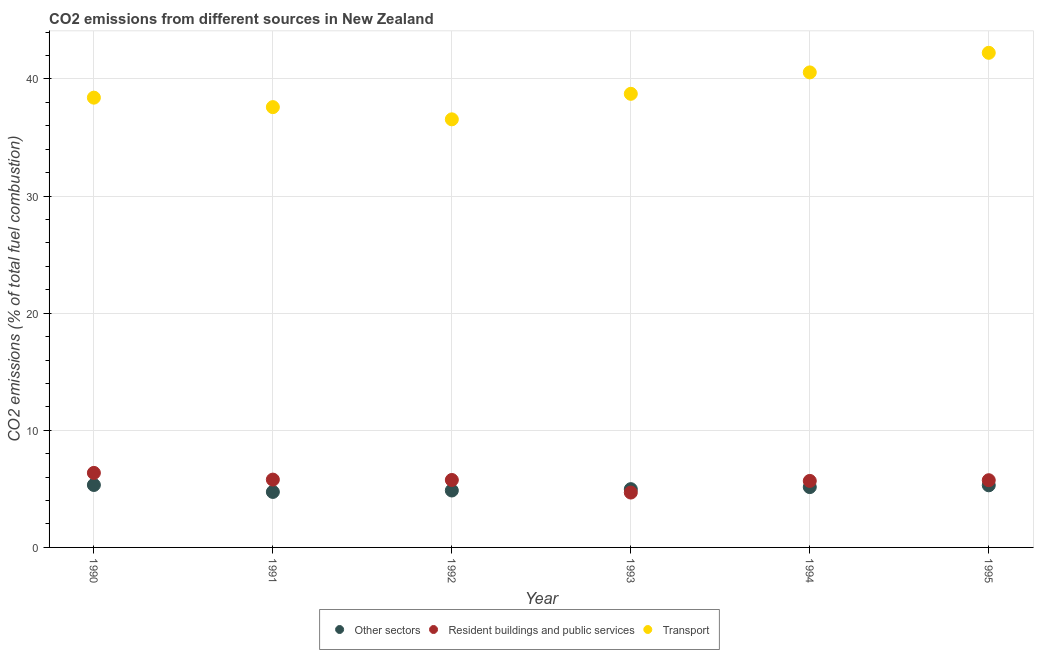How many different coloured dotlines are there?
Make the answer very short. 3. Is the number of dotlines equal to the number of legend labels?
Your response must be concise. Yes. What is the percentage of co2 emissions from transport in 1991?
Your answer should be compact. 37.59. Across all years, what is the maximum percentage of co2 emissions from resident buildings and public services?
Your response must be concise. 6.36. Across all years, what is the minimum percentage of co2 emissions from other sectors?
Offer a very short reply. 4.74. In which year was the percentage of co2 emissions from resident buildings and public services minimum?
Offer a terse response. 1993. What is the total percentage of co2 emissions from transport in the graph?
Provide a short and direct response. 234.03. What is the difference between the percentage of co2 emissions from transport in 1990 and that in 1991?
Provide a succinct answer. 0.81. What is the difference between the percentage of co2 emissions from resident buildings and public services in 1993 and the percentage of co2 emissions from other sectors in 1991?
Make the answer very short. -0.05. What is the average percentage of co2 emissions from resident buildings and public services per year?
Provide a short and direct response. 5.67. In the year 1991, what is the difference between the percentage of co2 emissions from other sectors and percentage of co2 emissions from transport?
Give a very brief answer. -32.85. In how many years, is the percentage of co2 emissions from resident buildings and public services greater than 14 %?
Keep it short and to the point. 0. What is the ratio of the percentage of co2 emissions from other sectors in 1991 to that in 1995?
Your answer should be very brief. 0.89. Is the difference between the percentage of co2 emissions from transport in 1991 and 1992 greater than the difference between the percentage of co2 emissions from resident buildings and public services in 1991 and 1992?
Provide a short and direct response. Yes. What is the difference between the highest and the second highest percentage of co2 emissions from transport?
Offer a very short reply. 1.67. What is the difference between the highest and the lowest percentage of co2 emissions from resident buildings and public services?
Your response must be concise. 1.68. In how many years, is the percentage of co2 emissions from resident buildings and public services greater than the average percentage of co2 emissions from resident buildings and public services taken over all years?
Make the answer very short. 5. Is it the case that in every year, the sum of the percentage of co2 emissions from other sectors and percentage of co2 emissions from resident buildings and public services is greater than the percentage of co2 emissions from transport?
Provide a succinct answer. No. Does the percentage of co2 emissions from transport monotonically increase over the years?
Your answer should be very brief. No. Is the percentage of co2 emissions from transport strictly greater than the percentage of co2 emissions from other sectors over the years?
Your answer should be compact. Yes. How many dotlines are there?
Provide a short and direct response. 3. How many years are there in the graph?
Your response must be concise. 6. Are the values on the major ticks of Y-axis written in scientific E-notation?
Your answer should be very brief. No. Does the graph contain grids?
Give a very brief answer. Yes. How are the legend labels stacked?
Your response must be concise. Horizontal. What is the title of the graph?
Keep it short and to the point. CO2 emissions from different sources in New Zealand. What is the label or title of the X-axis?
Your answer should be very brief. Year. What is the label or title of the Y-axis?
Make the answer very short. CO2 emissions (% of total fuel combustion). What is the CO2 emissions (% of total fuel combustion) in Other sectors in 1990?
Offer a terse response. 5.33. What is the CO2 emissions (% of total fuel combustion) in Resident buildings and public services in 1990?
Your answer should be very brief. 6.36. What is the CO2 emissions (% of total fuel combustion) of Transport in 1990?
Offer a very short reply. 38.4. What is the CO2 emissions (% of total fuel combustion) in Other sectors in 1991?
Provide a succinct answer. 4.74. What is the CO2 emissions (% of total fuel combustion) of Resident buildings and public services in 1991?
Make the answer very short. 5.79. What is the CO2 emissions (% of total fuel combustion) of Transport in 1991?
Give a very brief answer. 37.59. What is the CO2 emissions (% of total fuel combustion) in Other sectors in 1992?
Your answer should be very brief. 4.86. What is the CO2 emissions (% of total fuel combustion) in Resident buildings and public services in 1992?
Ensure brevity in your answer.  5.76. What is the CO2 emissions (% of total fuel combustion) in Transport in 1992?
Provide a succinct answer. 36.55. What is the CO2 emissions (% of total fuel combustion) in Other sectors in 1993?
Offer a terse response. 4.98. What is the CO2 emissions (% of total fuel combustion) in Resident buildings and public services in 1993?
Ensure brevity in your answer.  4.68. What is the CO2 emissions (% of total fuel combustion) in Transport in 1993?
Your answer should be very brief. 38.72. What is the CO2 emissions (% of total fuel combustion) in Other sectors in 1994?
Ensure brevity in your answer.  5.15. What is the CO2 emissions (% of total fuel combustion) of Resident buildings and public services in 1994?
Offer a very short reply. 5.68. What is the CO2 emissions (% of total fuel combustion) in Transport in 1994?
Your answer should be compact. 40.55. What is the CO2 emissions (% of total fuel combustion) in Other sectors in 1995?
Ensure brevity in your answer.  5.3. What is the CO2 emissions (% of total fuel combustion) of Resident buildings and public services in 1995?
Make the answer very short. 5.74. What is the CO2 emissions (% of total fuel combustion) of Transport in 1995?
Make the answer very short. 42.22. Across all years, what is the maximum CO2 emissions (% of total fuel combustion) in Other sectors?
Keep it short and to the point. 5.33. Across all years, what is the maximum CO2 emissions (% of total fuel combustion) in Resident buildings and public services?
Provide a succinct answer. 6.36. Across all years, what is the maximum CO2 emissions (% of total fuel combustion) of Transport?
Make the answer very short. 42.22. Across all years, what is the minimum CO2 emissions (% of total fuel combustion) of Other sectors?
Keep it short and to the point. 4.74. Across all years, what is the minimum CO2 emissions (% of total fuel combustion) in Resident buildings and public services?
Provide a short and direct response. 4.68. Across all years, what is the minimum CO2 emissions (% of total fuel combustion) of Transport?
Offer a very short reply. 36.55. What is the total CO2 emissions (% of total fuel combustion) in Other sectors in the graph?
Your answer should be very brief. 30.36. What is the total CO2 emissions (% of total fuel combustion) in Resident buildings and public services in the graph?
Give a very brief answer. 34.01. What is the total CO2 emissions (% of total fuel combustion) of Transport in the graph?
Ensure brevity in your answer.  234.03. What is the difference between the CO2 emissions (% of total fuel combustion) in Other sectors in 1990 and that in 1991?
Give a very brief answer. 0.59. What is the difference between the CO2 emissions (% of total fuel combustion) in Resident buildings and public services in 1990 and that in 1991?
Offer a very short reply. 0.57. What is the difference between the CO2 emissions (% of total fuel combustion) in Transport in 1990 and that in 1991?
Give a very brief answer. 0.81. What is the difference between the CO2 emissions (% of total fuel combustion) of Other sectors in 1990 and that in 1992?
Give a very brief answer. 0.47. What is the difference between the CO2 emissions (% of total fuel combustion) in Resident buildings and public services in 1990 and that in 1992?
Make the answer very short. 0.6. What is the difference between the CO2 emissions (% of total fuel combustion) of Transport in 1990 and that in 1992?
Provide a succinct answer. 1.85. What is the difference between the CO2 emissions (% of total fuel combustion) of Other sectors in 1990 and that in 1993?
Give a very brief answer. 0.36. What is the difference between the CO2 emissions (% of total fuel combustion) of Resident buildings and public services in 1990 and that in 1993?
Give a very brief answer. 1.68. What is the difference between the CO2 emissions (% of total fuel combustion) of Transport in 1990 and that in 1993?
Ensure brevity in your answer.  -0.33. What is the difference between the CO2 emissions (% of total fuel combustion) of Other sectors in 1990 and that in 1994?
Ensure brevity in your answer.  0.18. What is the difference between the CO2 emissions (% of total fuel combustion) of Resident buildings and public services in 1990 and that in 1994?
Ensure brevity in your answer.  0.68. What is the difference between the CO2 emissions (% of total fuel combustion) in Transport in 1990 and that in 1994?
Your answer should be very brief. -2.16. What is the difference between the CO2 emissions (% of total fuel combustion) in Other sectors in 1990 and that in 1995?
Keep it short and to the point. 0.03. What is the difference between the CO2 emissions (% of total fuel combustion) in Resident buildings and public services in 1990 and that in 1995?
Offer a terse response. 0.62. What is the difference between the CO2 emissions (% of total fuel combustion) of Transport in 1990 and that in 1995?
Give a very brief answer. -3.83. What is the difference between the CO2 emissions (% of total fuel combustion) in Other sectors in 1991 and that in 1992?
Provide a succinct answer. -0.12. What is the difference between the CO2 emissions (% of total fuel combustion) in Resident buildings and public services in 1991 and that in 1992?
Provide a short and direct response. 0.03. What is the difference between the CO2 emissions (% of total fuel combustion) of Transport in 1991 and that in 1992?
Offer a very short reply. 1.04. What is the difference between the CO2 emissions (% of total fuel combustion) in Other sectors in 1991 and that in 1993?
Ensure brevity in your answer.  -0.24. What is the difference between the CO2 emissions (% of total fuel combustion) of Resident buildings and public services in 1991 and that in 1993?
Provide a succinct answer. 1.1. What is the difference between the CO2 emissions (% of total fuel combustion) of Transport in 1991 and that in 1993?
Provide a succinct answer. -1.14. What is the difference between the CO2 emissions (% of total fuel combustion) in Other sectors in 1991 and that in 1994?
Your answer should be compact. -0.41. What is the difference between the CO2 emissions (% of total fuel combustion) of Resident buildings and public services in 1991 and that in 1994?
Give a very brief answer. 0.11. What is the difference between the CO2 emissions (% of total fuel combustion) of Transport in 1991 and that in 1994?
Keep it short and to the point. -2.96. What is the difference between the CO2 emissions (% of total fuel combustion) in Other sectors in 1991 and that in 1995?
Make the answer very short. -0.57. What is the difference between the CO2 emissions (% of total fuel combustion) of Resident buildings and public services in 1991 and that in 1995?
Provide a short and direct response. 0.05. What is the difference between the CO2 emissions (% of total fuel combustion) in Transport in 1991 and that in 1995?
Offer a terse response. -4.64. What is the difference between the CO2 emissions (% of total fuel combustion) of Other sectors in 1992 and that in 1993?
Provide a short and direct response. -0.12. What is the difference between the CO2 emissions (% of total fuel combustion) of Resident buildings and public services in 1992 and that in 1993?
Your answer should be compact. 1.07. What is the difference between the CO2 emissions (% of total fuel combustion) in Transport in 1992 and that in 1993?
Offer a terse response. -2.18. What is the difference between the CO2 emissions (% of total fuel combustion) of Other sectors in 1992 and that in 1994?
Offer a terse response. -0.29. What is the difference between the CO2 emissions (% of total fuel combustion) in Resident buildings and public services in 1992 and that in 1994?
Keep it short and to the point. 0.08. What is the difference between the CO2 emissions (% of total fuel combustion) in Transport in 1992 and that in 1994?
Your response must be concise. -4.01. What is the difference between the CO2 emissions (% of total fuel combustion) of Other sectors in 1992 and that in 1995?
Your response must be concise. -0.44. What is the difference between the CO2 emissions (% of total fuel combustion) of Resident buildings and public services in 1992 and that in 1995?
Make the answer very short. 0.02. What is the difference between the CO2 emissions (% of total fuel combustion) of Transport in 1992 and that in 1995?
Provide a short and direct response. -5.68. What is the difference between the CO2 emissions (% of total fuel combustion) in Other sectors in 1993 and that in 1994?
Make the answer very short. -0.17. What is the difference between the CO2 emissions (% of total fuel combustion) in Resident buildings and public services in 1993 and that in 1994?
Provide a short and direct response. -0.99. What is the difference between the CO2 emissions (% of total fuel combustion) in Transport in 1993 and that in 1994?
Provide a succinct answer. -1.83. What is the difference between the CO2 emissions (% of total fuel combustion) of Other sectors in 1993 and that in 1995?
Keep it short and to the point. -0.33. What is the difference between the CO2 emissions (% of total fuel combustion) in Resident buildings and public services in 1993 and that in 1995?
Your response must be concise. -1.05. What is the difference between the CO2 emissions (% of total fuel combustion) in Transport in 1993 and that in 1995?
Provide a succinct answer. -3.5. What is the difference between the CO2 emissions (% of total fuel combustion) in Other sectors in 1994 and that in 1995?
Your answer should be very brief. -0.15. What is the difference between the CO2 emissions (% of total fuel combustion) in Resident buildings and public services in 1994 and that in 1995?
Your answer should be very brief. -0.06. What is the difference between the CO2 emissions (% of total fuel combustion) in Transport in 1994 and that in 1995?
Keep it short and to the point. -1.67. What is the difference between the CO2 emissions (% of total fuel combustion) of Other sectors in 1990 and the CO2 emissions (% of total fuel combustion) of Resident buildings and public services in 1991?
Provide a succinct answer. -0.46. What is the difference between the CO2 emissions (% of total fuel combustion) in Other sectors in 1990 and the CO2 emissions (% of total fuel combustion) in Transport in 1991?
Offer a terse response. -32.26. What is the difference between the CO2 emissions (% of total fuel combustion) of Resident buildings and public services in 1990 and the CO2 emissions (% of total fuel combustion) of Transport in 1991?
Offer a very short reply. -31.23. What is the difference between the CO2 emissions (% of total fuel combustion) of Other sectors in 1990 and the CO2 emissions (% of total fuel combustion) of Resident buildings and public services in 1992?
Give a very brief answer. -0.43. What is the difference between the CO2 emissions (% of total fuel combustion) in Other sectors in 1990 and the CO2 emissions (% of total fuel combustion) in Transport in 1992?
Ensure brevity in your answer.  -31.21. What is the difference between the CO2 emissions (% of total fuel combustion) in Resident buildings and public services in 1990 and the CO2 emissions (% of total fuel combustion) in Transport in 1992?
Give a very brief answer. -30.18. What is the difference between the CO2 emissions (% of total fuel combustion) in Other sectors in 1990 and the CO2 emissions (% of total fuel combustion) in Resident buildings and public services in 1993?
Offer a terse response. 0.65. What is the difference between the CO2 emissions (% of total fuel combustion) in Other sectors in 1990 and the CO2 emissions (% of total fuel combustion) in Transport in 1993?
Offer a very short reply. -33.39. What is the difference between the CO2 emissions (% of total fuel combustion) of Resident buildings and public services in 1990 and the CO2 emissions (% of total fuel combustion) of Transport in 1993?
Keep it short and to the point. -32.36. What is the difference between the CO2 emissions (% of total fuel combustion) of Other sectors in 1990 and the CO2 emissions (% of total fuel combustion) of Resident buildings and public services in 1994?
Your answer should be compact. -0.35. What is the difference between the CO2 emissions (% of total fuel combustion) of Other sectors in 1990 and the CO2 emissions (% of total fuel combustion) of Transport in 1994?
Give a very brief answer. -35.22. What is the difference between the CO2 emissions (% of total fuel combustion) in Resident buildings and public services in 1990 and the CO2 emissions (% of total fuel combustion) in Transport in 1994?
Offer a very short reply. -34.19. What is the difference between the CO2 emissions (% of total fuel combustion) in Other sectors in 1990 and the CO2 emissions (% of total fuel combustion) in Resident buildings and public services in 1995?
Your answer should be compact. -0.41. What is the difference between the CO2 emissions (% of total fuel combustion) of Other sectors in 1990 and the CO2 emissions (% of total fuel combustion) of Transport in 1995?
Your answer should be very brief. -36.89. What is the difference between the CO2 emissions (% of total fuel combustion) in Resident buildings and public services in 1990 and the CO2 emissions (% of total fuel combustion) in Transport in 1995?
Offer a very short reply. -35.86. What is the difference between the CO2 emissions (% of total fuel combustion) in Other sectors in 1991 and the CO2 emissions (% of total fuel combustion) in Resident buildings and public services in 1992?
Keep it short and to the point. -1.02. What is the difference between the CO2 emissions (% of total fuel combustion) in Other sectors in 1991 and the CO2 emissions (% of total fuel combustion) in Transport in 1992?
Offer a very short reply. -31.81. What is the difference between the CO2 emissions (% of total fuel combustion) of Resident buildings and public services in 1991 and the CO2 emissions (% of total fuel combustion) of Transport in 1992?
Offer a very short reply. -30.76. What is the difference between the CO2 emissions (% of total fuel combustion) of Other sectors in 1991 and the CO2 emissions (% of total fuel combustion) of Resident buildings and public services in 1993?
Your response must be concise. 0.05. What is the difference between the CO2 emissions (% of total fuel combustion) in Other sectors in 1991 and the CO2 emissions (% of total fuel combustion) in Transport in 1993?
Provide a succinct answer. -33.99. What is the difference between the CO2 emissions (% of total fuel combustion) of Resident buildings and public services in 1991 and the CO2 emissions (% of total fuel combustion) of Transport in 1993?
Your answer should be very brief. -32.93. What is the difference between the CO2 emissions (% of total fuel combustion) of Other sectors in 1991 and the CO2 emissions (% of total fuel combustion) of Resident buildings and public services in 1994?
Your answer should be very brief. -0.94. What is the difference between the CO2 emissions (% of total fuel combustion) in Other sectors in 1991 and the CO2 emissions (% of total fuel combustion) in Transport in 1994?
Your answer should be compact. -35.81. What is the difference between the CO2 emissions (% of total fuel combustion) of Resident buildings and public services in 1991 and the CO2 emissions (% of total fuel combustion) of Transport in 1994?
Offer a very short reply. -34.76. What is the difference between the CO2 emissions (% of total fuel combustion) of Other sectors in 1991 and the CO2 emissions (% of total fuel combustion) of Resident buildings and public services in 1995?
Provide a short and direct response. -1. What is the difference between the CO2 emissions (% of total fuel combustion) of Other sectors in 1991 and the CO2 emissions (% of total fuel combustion) of Transport in 1995?
Ensure brevity in your answer.  -37.49. What is the difference between the CO2 emissions (% of total fuel combustion) of Resident buildings and public services in 1991 and the CO2 emissions (% of total fuel combustion) of Transport in 1995?
Ensure brevity in your answer.  -36.43. What is the difference between the CO2 emissions (% of total fuel combustion) of Other sectors in 1992 and the CO2 emissions (% of total fuel combustion) of Resident buildings and public services in 1993?
Offer a very short reply. 0.17. What is the difference between the CO2 emissions (% of total fuel combustion) of Other sectors in 1992 and the CO2 emissions (% of total fuel combustion) of Transport in 1993?
Your answer should be very brief. -33.86. What is the difference between the CO2 emissions (% of total fuel combustion) of Resident buildings and public services in 1992 and the CO2 emissions (% of total fuel combustion) of Transport in 1993?
Ensure brevity in your answer.  -32.97. What is the difference between the CO2 emissions (% of total fuel combustion) of Other sectors in 1992 and the CO2 emissions (% of total fuel combustion) of Resident buildings and public services in 1994?
Make the answer very short. -0.82. What is the difference between the CO2 emissions (% of total fuel combustion) in Other sectors in 1992 and the CO2 emissions (% of total fuel combustion) in Transport in 1994?
Make the answer very short. -35.69. What is the difference between the CO2 emissions (% of total fuel combustion) of Resident buildings and public services in 1992 and the CO2 emissions (% of total fuel combustion) of Transport in 1994?
Provide a short and direct response. -34.79. What is the difference between the CO2 emissions (% of total fuel combustion) in Other sectors in 1992 and the CO2 emissions (% of total fuel combustion) in Resident buildings and public services in 1995?
Offer a terse response. -0.88. What is the difference between the CO2 emissions (% of total fuel combustion) of Other sectors in 1992 and the CO2 emissions (% of total fuel combustion) of Transport in 1995?
Keep it short and to the point. -37.36. What is the difference between the CO2 emissions (% of total fuel combustion) in Resident buildings and public services in 1992 and the CO2 emissions (% of total fuel combustion) in Transport in 1995?
Ensure brevity in your answer.  -36.47. What is the difference between the CO2 emissions (% of total fuel combustion) in Other sectors in 1993 and the CO2 emissions (% of total fuel combustion) in Resident buildings and public services in 1994?
Your response must be concise. -0.7. What is the difference between the CO2 emissions (% of total fuel combustion) in Other sectors in 1993 and the CO2 emissions (% of total fuel combustion) in Transport in 1994?
Provide a succinct answer. -35.58. What is the difference between the CO2 emissions (% of total fuel combustion) of Resident buildings and public services in 1993 and the CO2 emissions (% of total fuel combustion) of Transport in 1994?
Offer a very short reply. -35.87. What is the difference between the CO2 emissions (% of total fuel combustion) of Other sectors in 1993 and the CO2 emissions (% of total fuel combustion) of Resident buildings and public services in 1995?
Offer a very short reply. -0.76. What is the difference between the CO2 emissions (% of total fuel combustion) of Other sectors in 1993 and the CO2 emissions (% of total fuel combustion) of Transport in 1995?
Your answer should be very brief. -37.25. What is the difference between the CO2 emissions (% of total fuel combustion) in Resident buildings and public services in 1993 and the CO2 emissions (% of total fuel combustion) in Transport in 1995?
Your answer should be very brief. -37.54. What is the difference between the CO2 emissions (% of total fuel combustion) of Other sectors in 1994 and the CO2 emissions (% of total fuel combustion) of Resident buildings and public services in 1995?
Give a very brief answer. -0.59. What is the difference between the CO2 emissions (% of total fuel combustion) of Other sectors in 1994 and the CO2 emissions (% of total fuel combustion) of Transport in 1995?
Provide a short and direct response. -37.07. What is the difference between the CO2 emissions (% of total fuel combustion) of Resident buildings and public services in 1994 and the CO2 emissions (% of total fuel combustion) of Transport in 1995?
Make the answer very short. -36.55. What is the average CO2 emissions (% of total fuel combustion) in Other sectors per year?
Make the answer very short. 5.06. What is the average CO2 emissions (% of total fuel combustion) of Resident buildings and public services per year?
Make the answer very short. 5.67. What is the average CO2 emissions (% of total fuel combustion) in Transport per year?
Your response must be concise. 39. In the year 1990, what is the difference between the CO2 emissions (% of total fuel combustion) of Other sectors and CO2 emissions (% of total fuel combustion) of Resident buildings and public services?
Provide a short and direct response. -1.03. In the year 1990, what is the difference between the CO2 emissions (% of total fuel combustion) of Other sectors and CO2 emissions (% of total fuel combustion) of Transport?
Provide a short and direct response. -33.06. In the year 1990, what is the difference between the CO2 emissions (% of total fuel combustion) in Resident buildings and public services and CO2 emissions (% of total fuel combustion) in Transport?
Your answer should be compact. -32.03. In the year 1991, what is the difference between the CO2 emissions (% of total fuel combustion) in Other sectors and CO2 emissions (% of total fuel combustion) in Resident buildings and public services?
Give a very brief answer. -1.05. In the year 1991, what is the difference between the CO2 emissions (% of total fuel combustion) in Other sectors and CO2 emissions (% of total fuel combustion) in Transport?
Provide a succinct answer. -32.85. In the year 1991, what is the difference between the CO2 emissions (% of total fuel combustion) of Resident buildings and public services and CO2 emissions (% of total fuel combustion) of Transport?
Provide a succinct answer. -31.8. In the year 1992, what is the difference between the CO2 emissions (% of total fuel combustion) of Other sectors and CO2 emissions (% of total fuel combustion) of Resident buildings and public services?
Keep it short and to the point. -0.9. In the year 1992, what is the difference between the CO2 emissions (% of total fuel combustion) of Other sectors and CO2 emissions (% of total fuel combustion) of Transport?
Your answer should be compact. -31.69. In the year 1992, what is the difference between the CO2 emissions (% of total fuel combustion) of Resident buildings and public services and CO2 emissions (% of total fuel combustion) of Transport?
Provide a short and direct response. -30.79. In the year 1993, what is the difference between the CO2 emissions (% of total fuel combustion) in Other sectors and CO2 emissions (% of total fuel combustion) in Resident buildings and public services?
Give a very brief answer. 0.29. In the year 1993, what is the difference between the CO2 emissions (% of total fuel combustion) in Other sectors and CO2 emissions (% of total fuel combustion) in Transport?
Offer a terse response. -33.75. In the year 1993, what is the difference between the CO2 emissions (% of total fuel combustion) in Resident buildings and public services and CO2 emissions (% of total fuel combustion) in Transport?
Ensure brevity in your answer.  -34.04. In the year 1994, what is the difference between the CO2 emissions (% of total fuel combustion) in Other sectors and CO2 emissions (% of total fuel combustion) in Resident buildings and public services?
Make the answer very short. -0.53. In the year 1994, what is the difference between the CO2 emissions (% of total fuel combustion) in Other sectors and CO2 emissions (% of total fuel combustion) in Transport?
Give a very brief answer. -35.4. In the year 1994, what is the difference between the CO2 emissions (% of total fuel combustion) in Resident buildings and public services and CO2 emissions (% of total fuel combustion) in Transport?
Your answer should be very brief. -34.87. In the year 1995, what is the difference between the CO2 emissions (% of total fuel combustion) in Other sectors and CO2 emissions (% of total fuel combustion) in Resident buildings and public services?
Ensure brevity in your answer.  -0.44. In the year 1995, what is the difference between the CO2 emissions (% of total fuel combustion) of Other sectors and CO2 emissions (% of total fuel combustion) of Transport?
Your answer should be very brief. -36.92. In the year 1995, what is the difference between the CO2 emissions (% of total fuel combustion) in Resident buildings and public services and CO2 emissions (% of total fuel combustion) in Transport?
Offer a very short reply. -36.49. What is the ratio of the CO2 emissions (% of total fuel combustion) in Other sectors in 1990 to that in 1991?
Your answer should be very brief. 1.13. What is the ratio of the CO2 emissions (% of total fuel combustion) of Resident buildings and public services in 1990 to that in 1991?
Offer a very short reply. 1.1. What is the ratio of the CO2 emissions (% of total fuel combustion) in Transport in 1990 to that in 1991?
Your response must be concise. 1.02. What is the ratio of the CO2 emissions (% of total fuel combustion) in Other sectors in 1990 to that in 1992?
Provide a short and direct response. 1.1. What is the ratio of the CO2 emissions (% of total fuel combustion) of Resident buildings and public services in 1990 to that in 1992?
Provide a short and direct response. 1.1. What is the ratio of the CO2 emissions (% of total fuel combustion) of Transport in 1990 to that in 1992?
Give a very brief answer. 1.05. What is the ratio of the CO2 emissions (% of total fuel combustion) in Other sectors in 1990 to that in 1993?
Ensure brevity in your answer.  1.07. What is the ratio of the CO2 emissions (% of total fuel combustion) of Resident buildings and public services in 1990 to that in 1993?
Make the answer very short. 1.36. What is the ratio of the CO2 emissions (% of total fuel combustion) of Transport in 1990 to that in 1993?
Provide a succinct answer. 0.99. What is the ratio of the CO2 emissions (% of total fuel combustion) of Other sectors in 1990 to that in 1994?
Offer a terse response. 1.04. What is the ratio of the CO2 emissions (% of total fuel combustion) of Resident buildings and public services in 1990 to that in 1994?
Ensure brevity in your answer.  1.12. What is the ratio of the CO2 emissions (% of total fuel combustion) of Transport in 1990 to that in 1994?
Make the answer very short. 0.95. What is the ratio of the CO2 emissions (% of total fuel combustion) in Other sectors in 1990 to that in 1995?
Offer a very short reply. 1.01. What is the ratio of the CO2 emissions (% of total fuel combustion) of Resident buildings and public services in 1990 to that in 1995?
Offer a terse response. 1.11. What is the ratio of the CO2 emissions (% of total fuel combustion) of Transport in 1990 to that in 1995?
Your answer should be compact. 0.91. What is the ratio of the CO2 emissions (% of total fuel combustion) in Other sectors in 1991 to that in 1992?
Offer a terse response. 0.97. What is the ratio of the CO2 emissions (% of total fuel combustion) of Resident buildings and public services in 1991 to that in 1992?
Offer a terse response. 1.01. What is the ratio of the CO2 emissions (% of total fuel combustion) in Transport in 1991 to that in 1992?
Give a very brief answer. 1.03. What is the ratio of the CO2 emissions (% of total fuel combustion) of Other sectors in 1991 to that in 1993?
Your response must be concise. 0.95. What is the ratio of the CO2 emissions (% of total fuel combustion) in Resident buildings and public services in 1991 to that in 1993?
Provide a short and direct response. 1.24. What is the ratio of the CO2 emissions (% of total fuel combustion) of Transport in 1991 to that in 1993?
Give a very brief answer. 0.97. What is the ratio of the CO2 emissions (% of total fuel combustion) in Other sectors in 1991 to that in 1994?
Your answer should be very brief. 0.92. What is the ratio of the CO2 emissions (% of total fuel combustion) of Resident buildings and public services in 1991 to that in 1994?
Offer a very short reply. 1.02. What is the ratio of the CO2 emissions (% of total fuel combustion) in Transport in 1991 to that in 1994?
Offer a terse response. 0.93. What is the ratio of the CO2 emissions (% of total fuel combustion) in Other sectors in 1991 to that in 1995?
Ensure brevity in your answer.  0.89. What is the ratio of the CO2 emissions (% of total fuel combustion) of Resident buildings and public services in 1991 to that in 1995?
Provide a succinct answer. 1.01. What is the ratio of the CO2 emissions (% of total fuel combustion) of Transport in 1991 to that in 1995?
Offer a terse response. 0.89. What is the ratio of the CO2 emissions (% of total fuel combustion) in Other sectors in 1992 to that in 1993?
Keep it short and to the point. 0.98. What is the ratio of the CO2 emissions (% of total fuel combustion) in Resident buildings and public services in 1992 to that in 1993?
Provide a succinct answer. 1.23. What is the ratio of the CO2 emissions (% of total fuel combustion) in Transport in 1992 to that in 1993?
Provide a succinct answer. 0.94. What is the ratio of the CO2 emissions (% of total fuel combustion) in Other sectors in 1992 to that in 1994?
Your answer should be very brief. 0.94. What is the ratio of the CO2 emissions (% of total fuel combustion) of Resident buildings and public services in 1992 to that in 1994?
Make the answer very short. 1.01. What is the ratio of the CO2 emissions (% of total fuel combustion) of Transport in 1992 to that in 1994?
Give a very brief answer. 0.9. What is the ratio of the CO2 emissions (% of total fuel combustion) in Other sectors in 1992 to that in 1995?
Your response must be concise. 0.92. What is the ratio of the CO2 emissions (% of total fuel combustion) of Resident buildings and public services in 1992 to that in 1995?
Offer a terse response. 1. What is the ratio of the CO2 emissions (% of total fuel combustion) in Transport in 1992 to that in 1995?
Give a very brief answer. 0.87. What is the ratio of the CO2 emissions (% of total fuel combustion) of Resident buildings and public services in 1993 to that in 1994?
Offer a very short reply. 0.83. What is the ratio of the CO2 emissions (% of total fuel combustion) in Transport in 1993 to that in 1994?
Your answer should be compact. 0.95. What is the ratio of the CO2 emissions (% of total fuel combustion) of Other sectors in 1993 to that in 1995?
Your response must be concise. 0.94. What is the ratio of the CO2 emissions (% of total fuel combustion) of Resident buildings and public services in 1993 to that in 1995?
Keep it short and to the point. 0.82. What is the ratio of the CO2 emissions (% of total fuel combustion) of Transport in 1993 to that in 1995?
Offer a terse response. 0.92. What is the ratio of the CO2 emissions (% of total fuel combustion) in Other sectors in 1994 to that in 1995?
Your answer should be compact. 0.97. What is the ratio of the CO2 emissions (% of total fuel combustion) of Transport in 1994 to that in 1995?
Offer a very short reply. 0.96. What is the difference between the highest and the second highest CO2 emissions (% of total fuel combustion) in Other sectors?
Make the answer very short. 0.03. What is the difference between the highest and the second highest CO2 emissions (% of total fuel combustion) of Resident buildings and public services?
Give a very brief answer. 0.57. What is the difference between the highest and the second highest CO2 emissions (% of total fuel combustion) of Transport?
Offer a terse response. 1.67. What is the difference between the highest and the lowest CO2 emissions (% of total fuel combustion) of Other sectors?
Give a very brief answer. 0.59. What is the difference between the highest and the lowest CO2 emissions (% of total fuel combustion) in Resident buildings and public services?
Your response must be concise. 1.68. What is the difference between the highest and the lowest CO2 emissions (% of total fuel combustion) in Transport?
Make the answer very short. 5.68. 